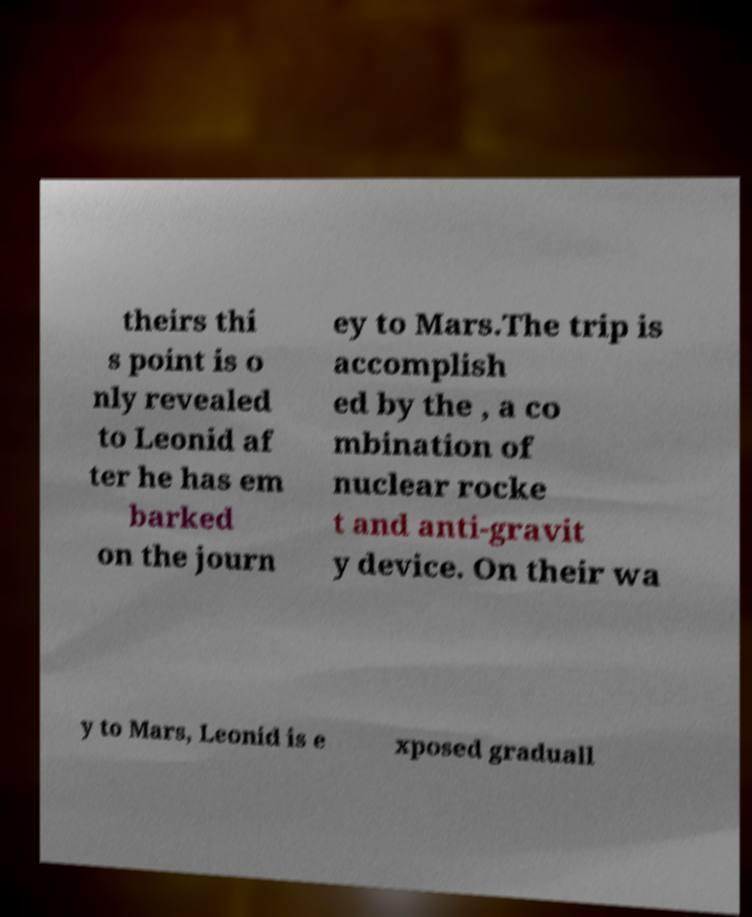I need the written content from this picture converted into text. Can you do that? theirs thi s point is o nly revealed to Leonid af ter he has em barked on the journ ey to Mars.The trip is accomplish ed by the , a co mbination of nuclear rocke t and anti-gravit y device. On their wa y to Mars, Leonid is e xposed graduall 